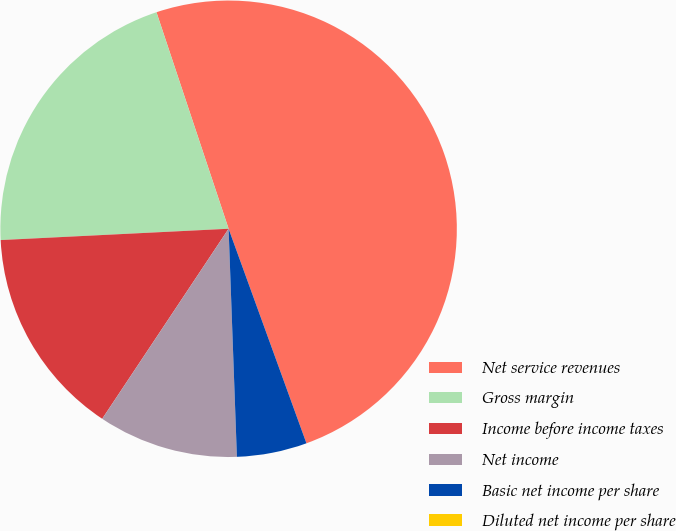Convert chart to OTSL. <chart><loc_0><loc_0><loc_500><loc_500><pie_chart><fcel>Net service revenues<fcel>Gross margin<fcel>Income before income taxes<fcel>Net income<fcel>Basic net income per share<fcel>Diluted net income per share<nl><fcel>49.58%<fcel>20.67%<fcel>14.87%<fcel>9.92%<fcel>4.96%<fcel>0.0%<nl></chart> 